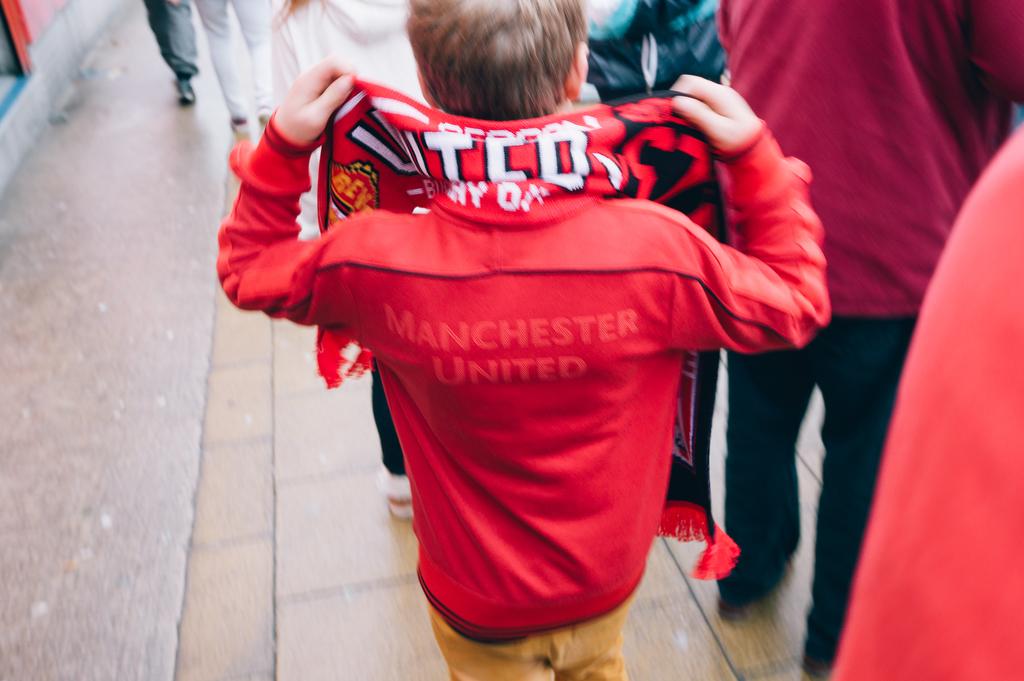What soccer team is he a fan of?
Make the answer very short. Manchester united. Is there white text on the shirt?
Keep it short and to the point. Yes. 